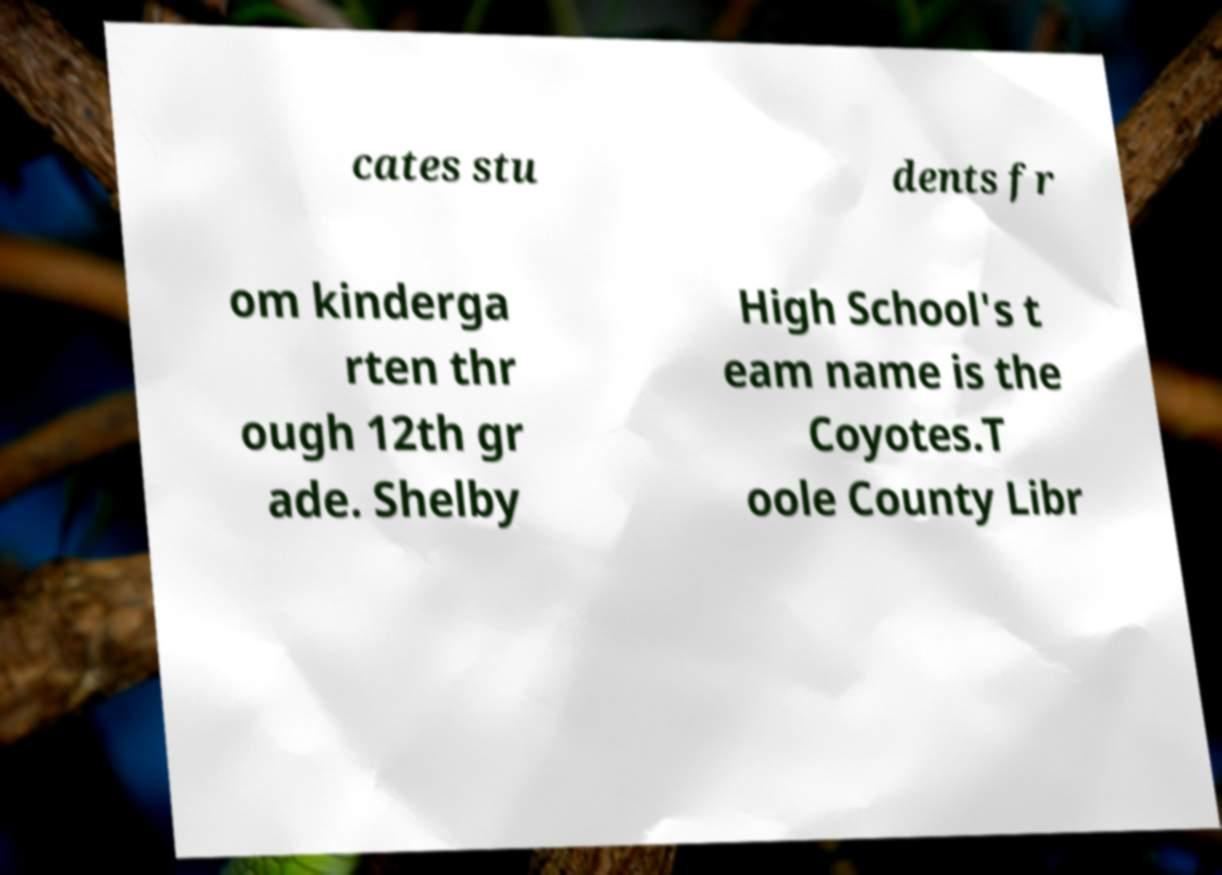Please read and relay the text visible in this image. What does it say? cates stu dents fr om kinderga rten thr ough 12th gr ade. Shelby High School's t eam name is the Coyotes.T oole County Libr 